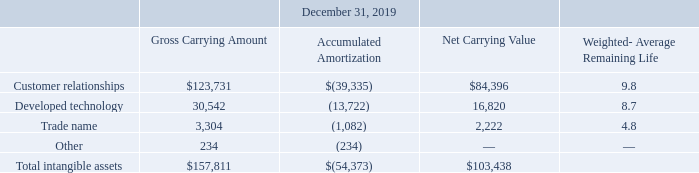We recorded $14.2 million, $15.2 million and $12.3 million of amortization related to our intangible assets for the years ended December 31, 2019, 2018 and 2017, respectively. There were no impairments of long-lived assets during the years ended December 31, 2019, 2018 and 2017.
The following tables reflect the weighted-average remaining life and carrying value of finite-lived intangible assets (in thousands, except weighted-average remaining life):
What was the amortization related to the company's intangible assets in 2019?
Answer scale should be: million. $14.2 million. What was the trade name gross carrying amount in 2019?
Answer scale should be: thousand. 3,304. What was the accumulated amortization for Other in 2019?
Answer scale should be: thousand. 234. How many intangible assets in 2019 had a net carrying value of more than $50,000 thousand? Customer relationships
Answer: 1. What is the percentage constitution of the gross carrying amount of customer relationships among the total gross carrying amount of the total intangible assets?
Answer scale should be: percent. 123,731/157,811
Answer: 78.4. What is the difference in the net carrying value between customer relationships and developed technology?
Answer scale should be: thousand. 84,396-16,820
Answer: 67576. 